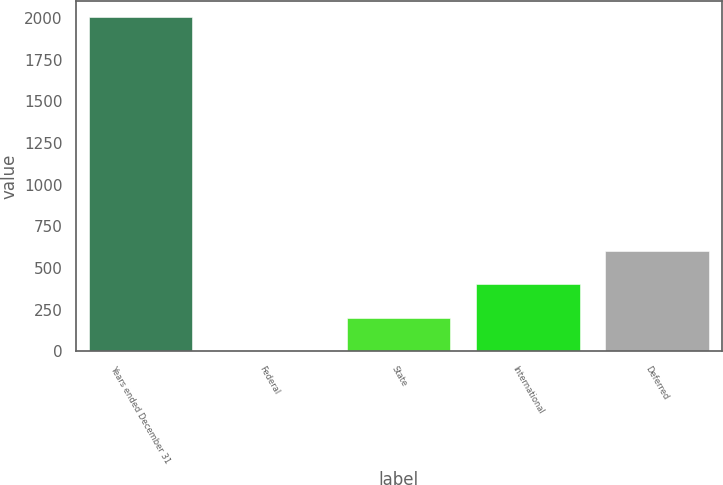Convert chart. <chart><loc_0><loc_0><loc_500><loc_500><bar_chart><fcel>Years ended December 31<fcel>Federal<fcel>State<fcel>International<fcel>Deferred<nl><fcel>2004<fcel>0.8<fcel>201.12<fcel>401.44<fcel>601.76<nl></chart> 